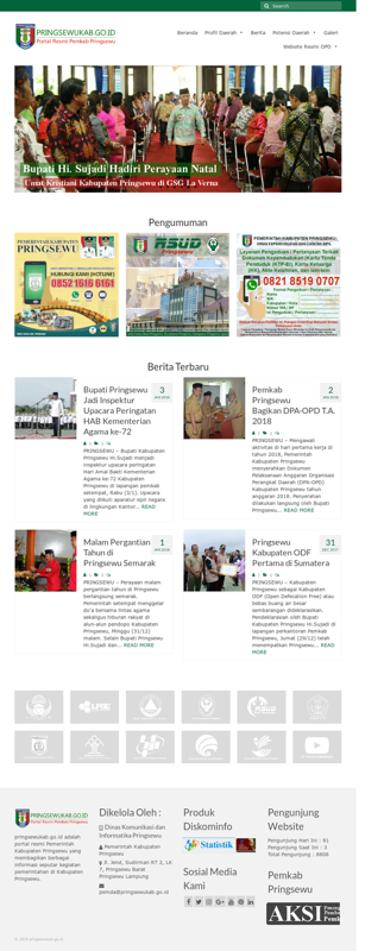What is the website mentioned in the image? The website prominently displayed in the image is NGSEWUKAB.GO.ID, which appears to be an official government site given the '.GO.ID' domain typically used by Indonesian government entities. 